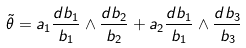<formula> <loc_0><loc_0><loc_500><loc_500>\tilde { \theta } = a _ { 1 } \frac { d b _ { 1 } } { b _ { 1 } } \wedge \frac { d b _ { 2 } } { b _ { 2 } } + a _ { 2 } \frac { d b _ { 1 } } { b _ { 1 } } \wedge \frac { d b _ { 3 } } { b _ { 3 } }</formula> 